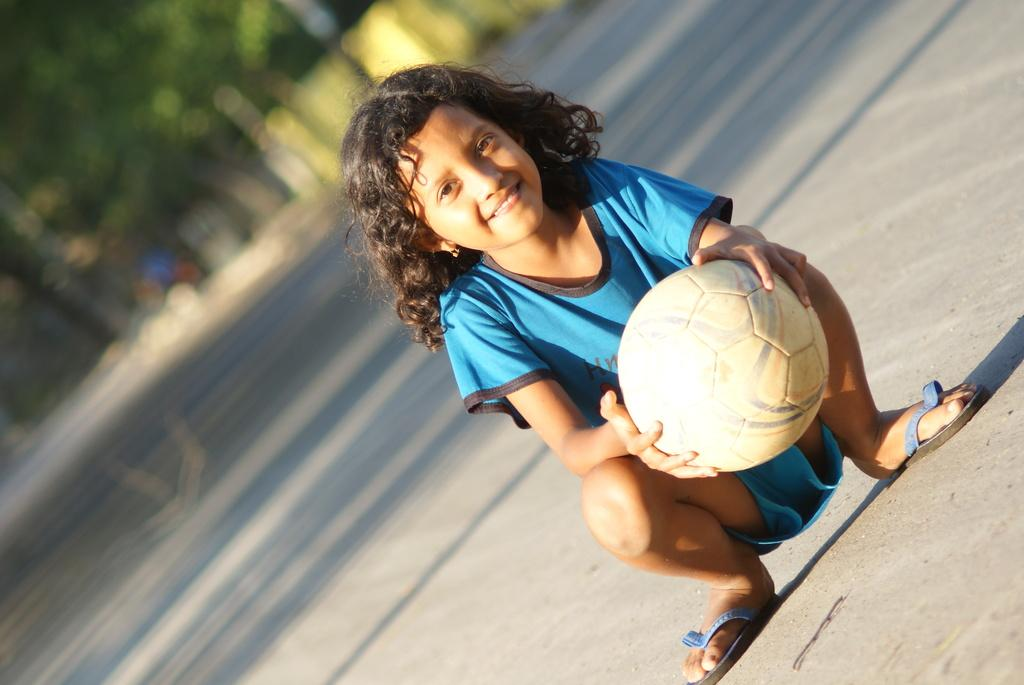What is the main subject of the image? The main subject of the image is a kid. What is the kid doing in the image? The kid is sitting on the road and holding a ball in his hand. What is the kid's body position in the image? The kid is in a squat position. What is the kid's facial expression in the image? The kid is smiling. How would you describe the background of the image? The background of the image is blurred. What type of fruit is the kid holding in the image? The kid is not holding any fruit in the image; he is holding a ball. What sound does the kid make when he sees the paint in the image? There is no paint present in the image, so the kid cannot make any sound related to paint. 